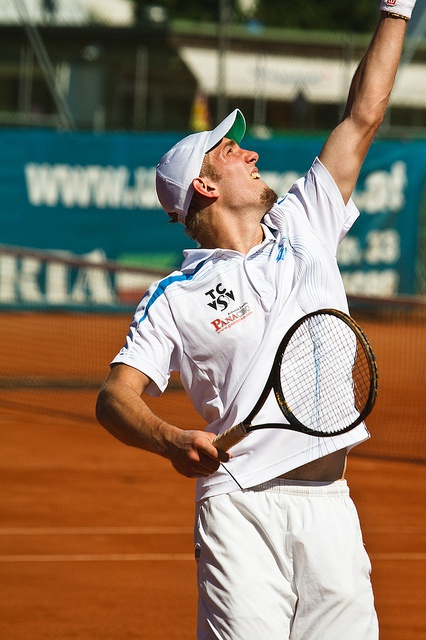Describe the objects in this image and their specific colors. I can see people in lightgray, white, maroon, darkgray, and black tones and tennis racket in lightgray, white, black, maroon, and darkgray tones in this image. 